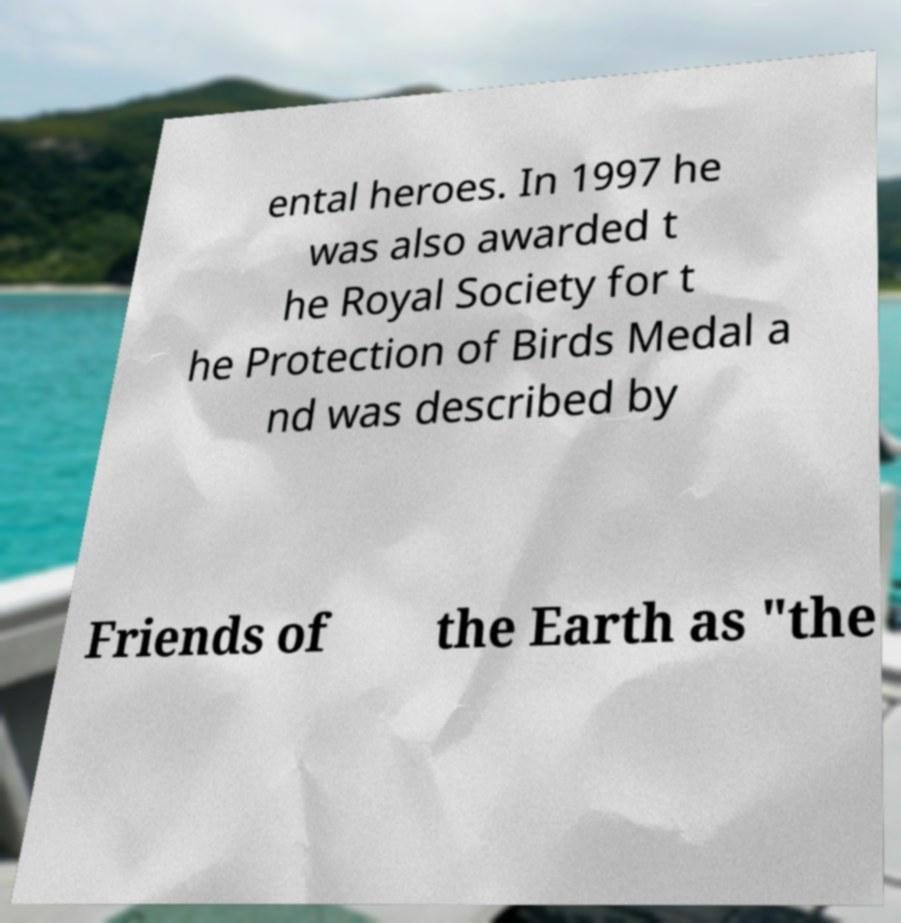For documentation purposes, I need the text within this image transcribed. Could you provide that? ental heroes. In 1997 he was also awarded t he Royal Society for t he Protection of Birds Medal a nd was described by Friends of the Earth as "the 